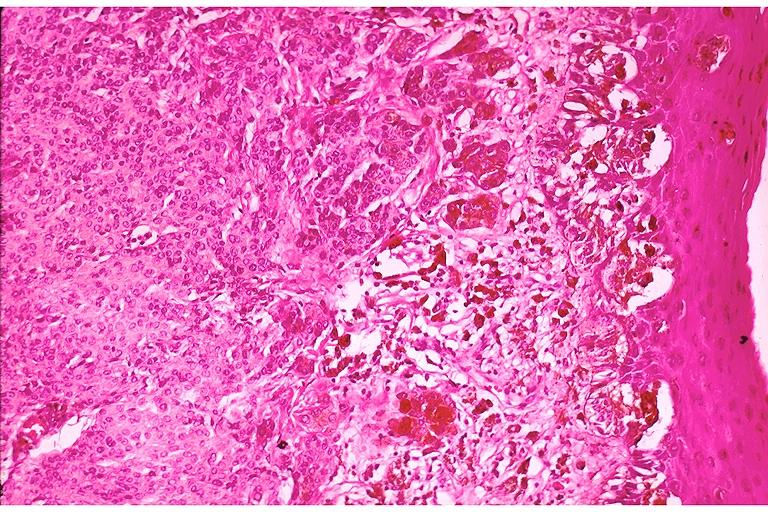what does this image show?
Answer the question using a single word or phrase. Compound nevus 